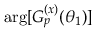Convert formula to latex. <formula><loc_0><loc_0><loc_500><loc_500>\arg [ G _ { p } ^ { ( x ) } ( \theta _ { 1 } ) ]</formula> 